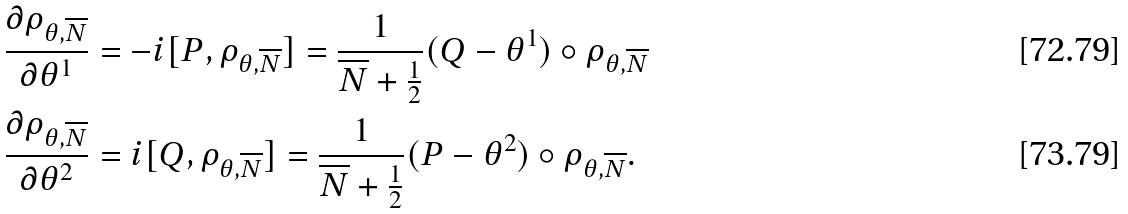<formula> <loc_0><loc_0><loc_500><loc_500>\frac { \partial \rho _ { \theta , \overline { N } } } { \partial \theta ^ { 1 } } & = - i [ P , \rho _ { \theta , \overline { N } } ] = \frac { 1 } { \overline { N } + \frac { 1 } { 2 } } ( Q - \theta ^ { 1 } ) \circ \rho _ { \theta , \overline { N } } \\ \frac { \partial \rho _ { \theta , \overline { N } } } { \partial \theta ^ { 2 } } & = i [ Q , \rho _ { \theta , \overline { N } } ] = \frac { 1 } { \overline { N } + \frac { 1 } { 2 } } ( P - \theta ^ { 2 } ) \circ \rho _ { \theta , \overline { N } } .</formula> 